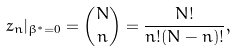Convert formula to latex. <formula><loc_0><loc_0><loc_500><loc_500>z _ { n } | _ { \beta ^ { * } = 0 } = \binom { N } { n } = \frac { N ! } { n ! ( N - n ) ! } ,</formula> 